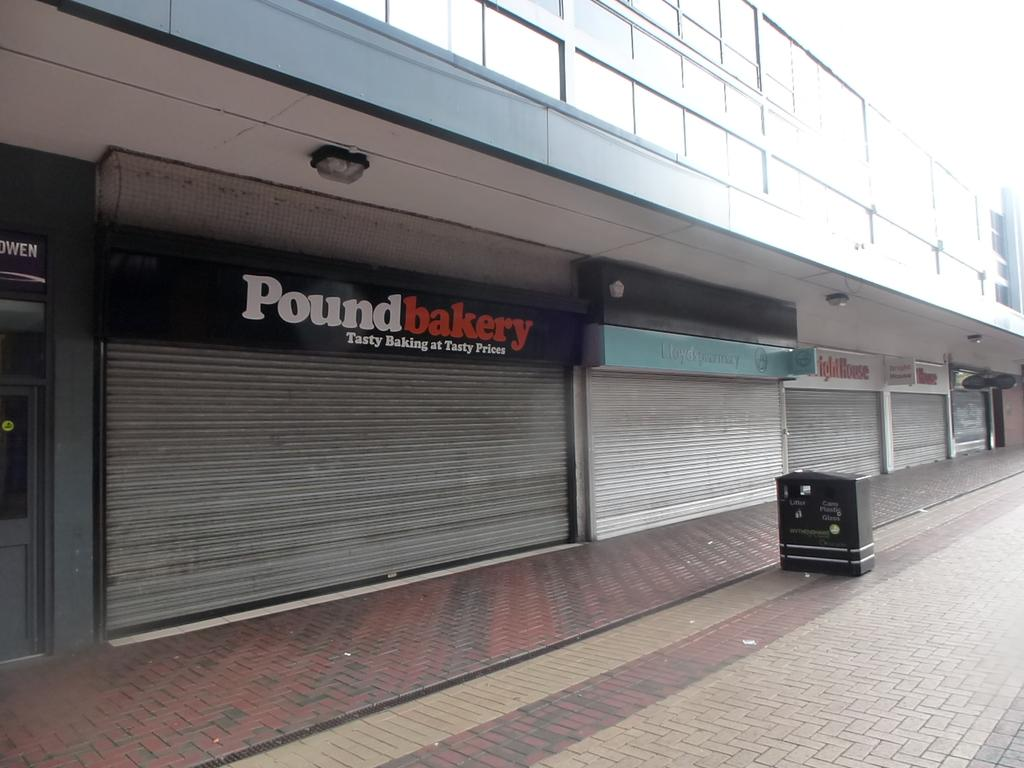<image>
Render a clear and concise summary of the photo. An empty street and the outside of the pound bakery. 